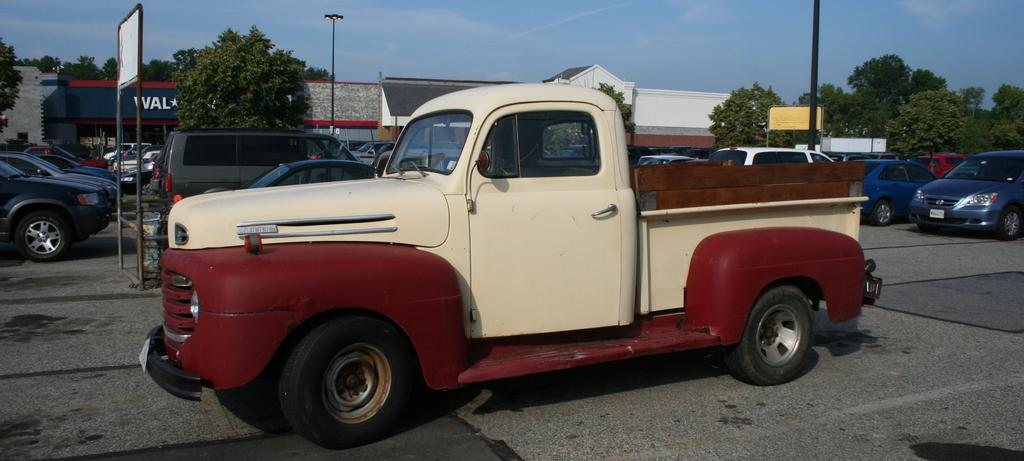What type of infrastructure can be seen in the image? There are roads in the image. What other objects are present in the image? There are boards and poles in the image. What can be seen in the background of the image? There are trees and buildings in the background of the image. What type of ice can be seen melting on the boards in the image? There is no ice present in the image; it only features roads, boards, poles, trees, and buildings. What type of celery is growing near the poles in the image? There is no celery present in the image; it only features roads, boards, poles, trees, and buildings. 